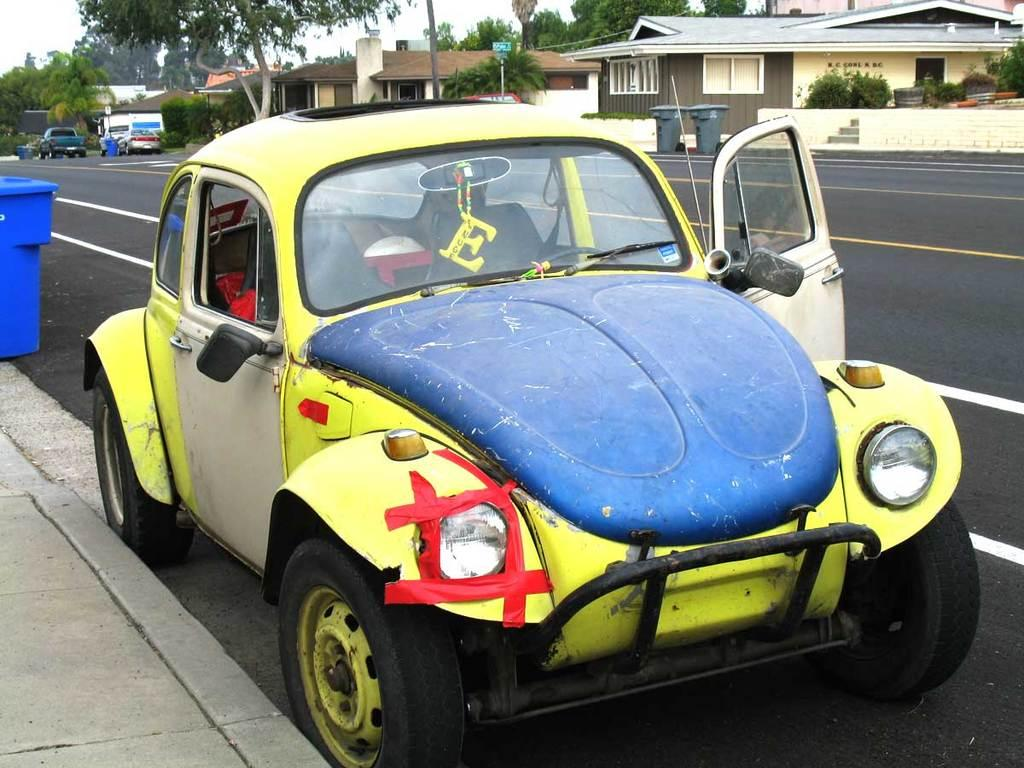What can be seen on the road in the image? There are vehicles on the road in the image. What is located on the left side of the image? There is a walkway on the left side of the image. What objects are present on the walkway? Bins are present on the walkway. What can be seen in the background of the image? There are buildings, trees, and the sky visible in the background of the image. What type of coal is being used to fuel the vehicles in the image? There is no coal present in the image, and the vehicles are not fueled by coal. Can you see a hook attached to the buildings in the background of the image? There is no hook visible in the image; only buildings, trees, and the sky are present in the background. 